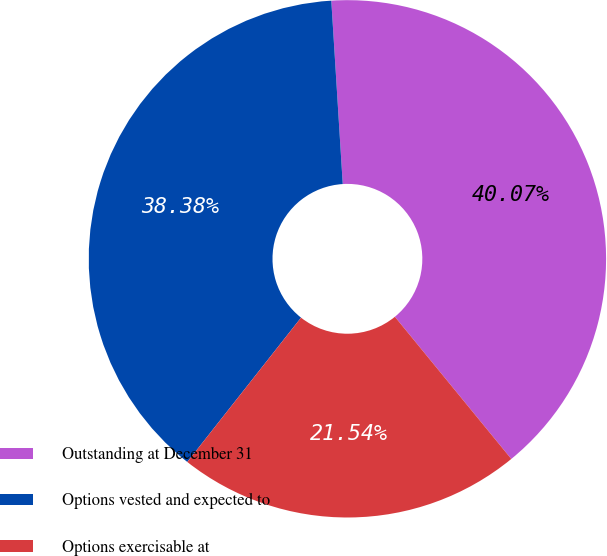<chart> <loc_0><loc_0><loc_500><loc_500><pie_chart><fcel>Outstanding at December 31<fcel>Options vested and expected to<fcel>Options exercisable at<nl><fcel>40.07%<fcel>38.38%<fcel>21.54%<nl></chart> 